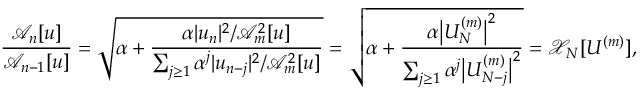<formula> <loc_0><loc_0><loc_500><loc_500>\frac { \mathcal { A } _ { n } [ u ] } { \mathcal { A } _ { n - 1 } [ u ] } = \sqrt { \alpha + \frac { \alpha | u _ { n } | ^ { 2 } / \mathcal { A } _ { m } ^ { 2 } [ u ] } { \sum _ { j \geq 1 } \alpha ^ { j } | u _ { n - j } | ^ { 2 } / \mathcal { A } _ { m } ^ { 2 } [ u ] } } = \sqrt { \alpha + \frac { \alpha \left | U _ { N } ^ { ( m ) } \right | ^ { 2 } } { \sum _ { j \geq 1 } { \alpha ^ { j } \left | U _ { N - j } ^ { ( m ) } \right | ^ { 2 } } } } = \mathcal { X } _ { N } [ U ^ { ( m ) } ] ,</formula> 